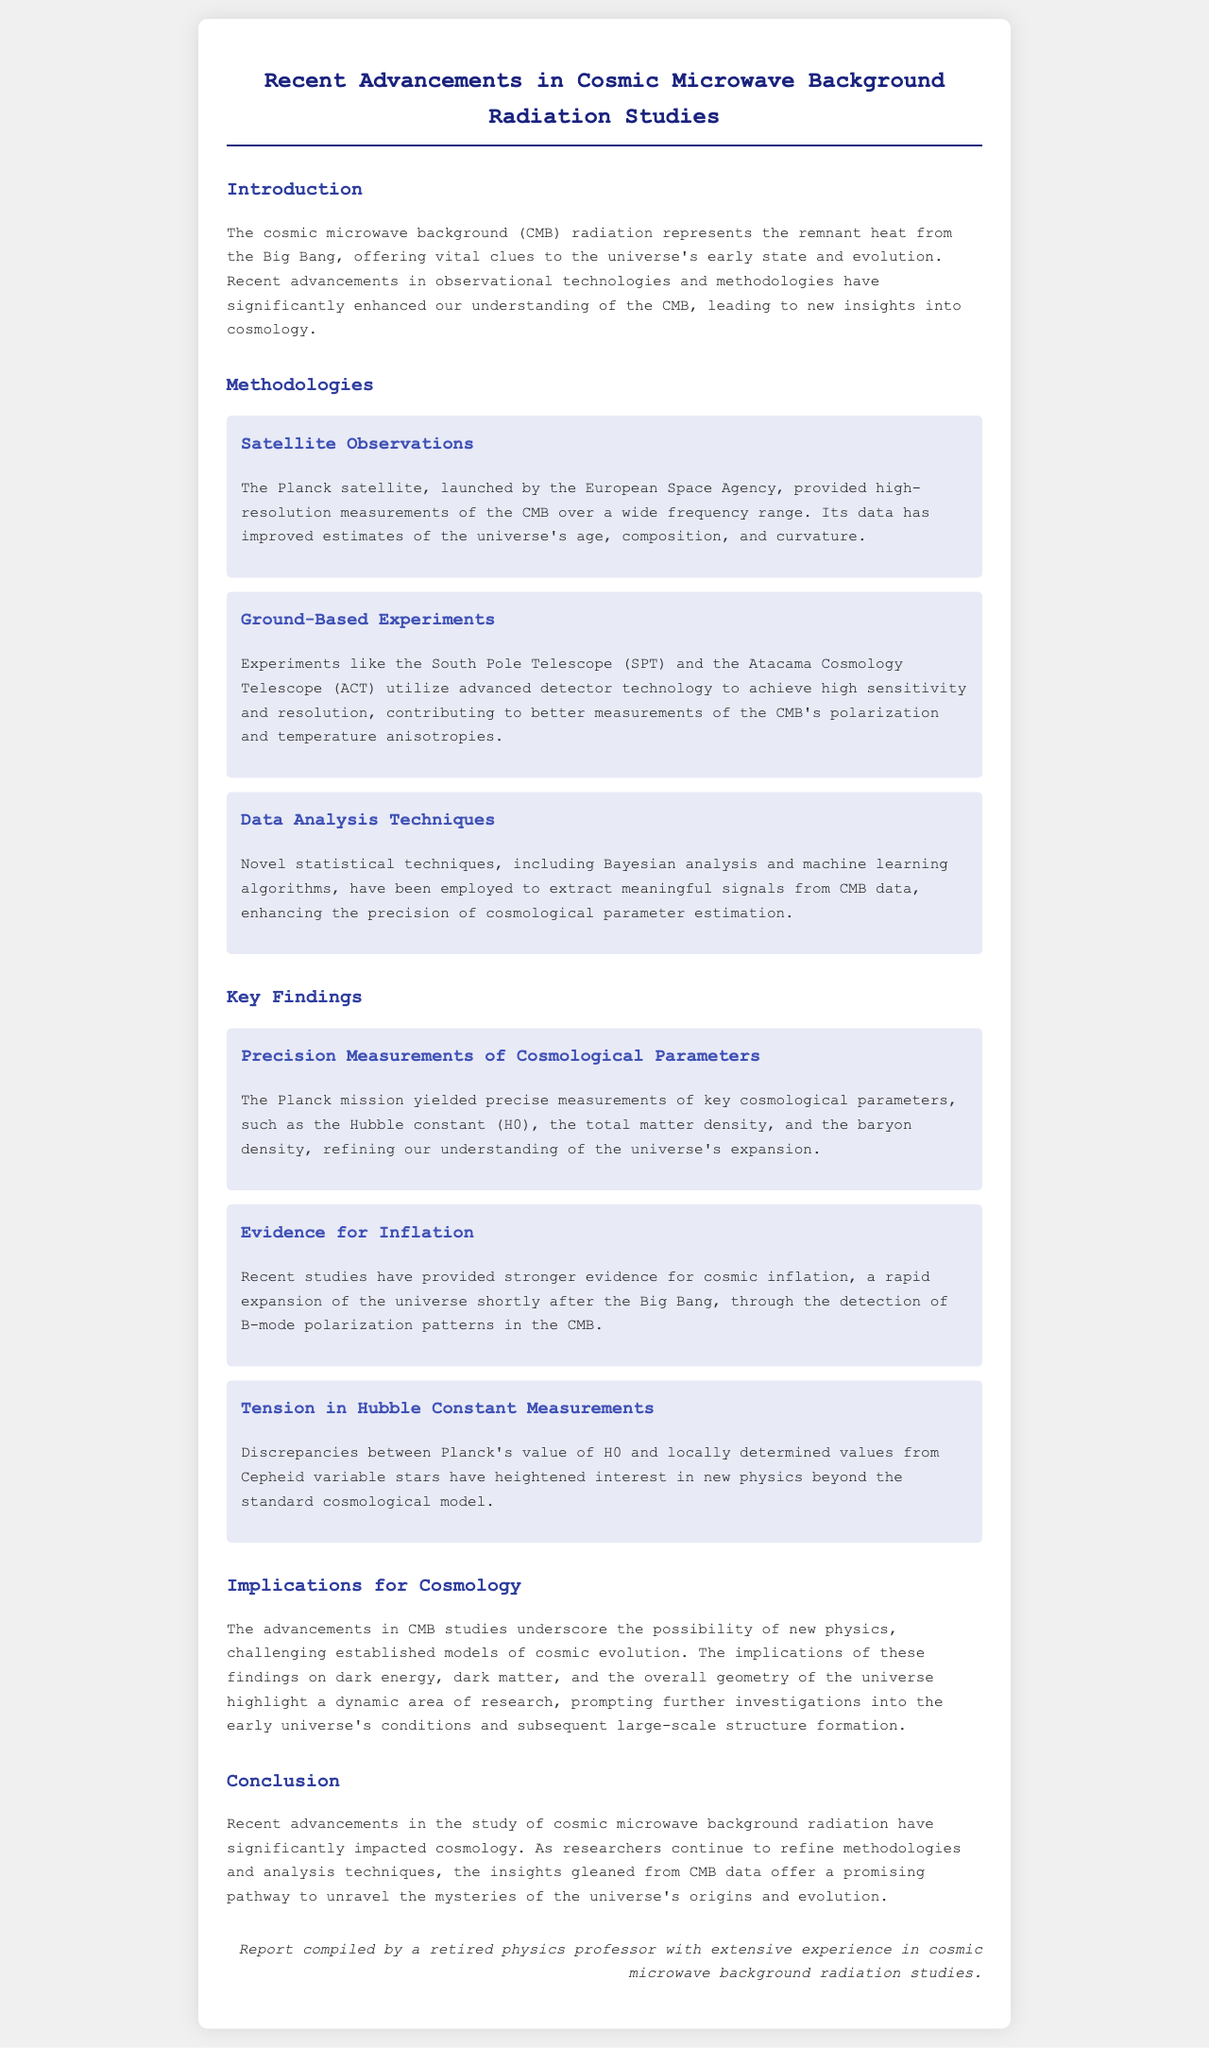What significant satellite contributed to CMB measurements? The document mentions that the Planck satellite, launched by the European Space Agency, provided high-resolution measurements of the CMB.
Answer: Planck satellite What are the two key ground-based experiments mentioned? The report lists the South Pole Telescope (SPT) and the Atacama Cosmology Telescope (ACT) as significant ground-based experiments.
Answer: SPT and ACT Which statistical techniques have enhanced CMB data analysis? The document states that Bayesian analysis and machine learning algorithms have been used for improved signal extraction from CMB data.
Answer: Bayesian analysis and machine learning What key cosmological parameter did the Planck mission measure with precision? The document highlights that the Planck mission yielded precise measurements of the Hubble constant (H0).
Answer: Hubble constant (H0) What evidence have recent studies provided regarding cosmic inflation? The report indicates that recent studies have provided stronger evidence for cosmic inflation through the detection of B-mode polarization patterns in the CMB.
Answer: B-mode polarization patterns What tension is highlighted regarding the Hubble constant? Discrepancies between Planck's value of H0 and locally determined values from Cepheid variable stars are noted in the document.
Answer: Discrepancies between values of H0 What do the advancements in CMB studies suggest about future research? The document discusses that advancements in CMB studies prompt further investigations into the early universe's conditions and large-scale structure formation.
Answer: Further investigations into early universe conditions What is the report's overall impact on cosmology? The report concludes that recent advancements in CMB studies have significantly impacted cosmology, leading to new insights into the universe's origins.
Answer: Significantly impacted cosmology 